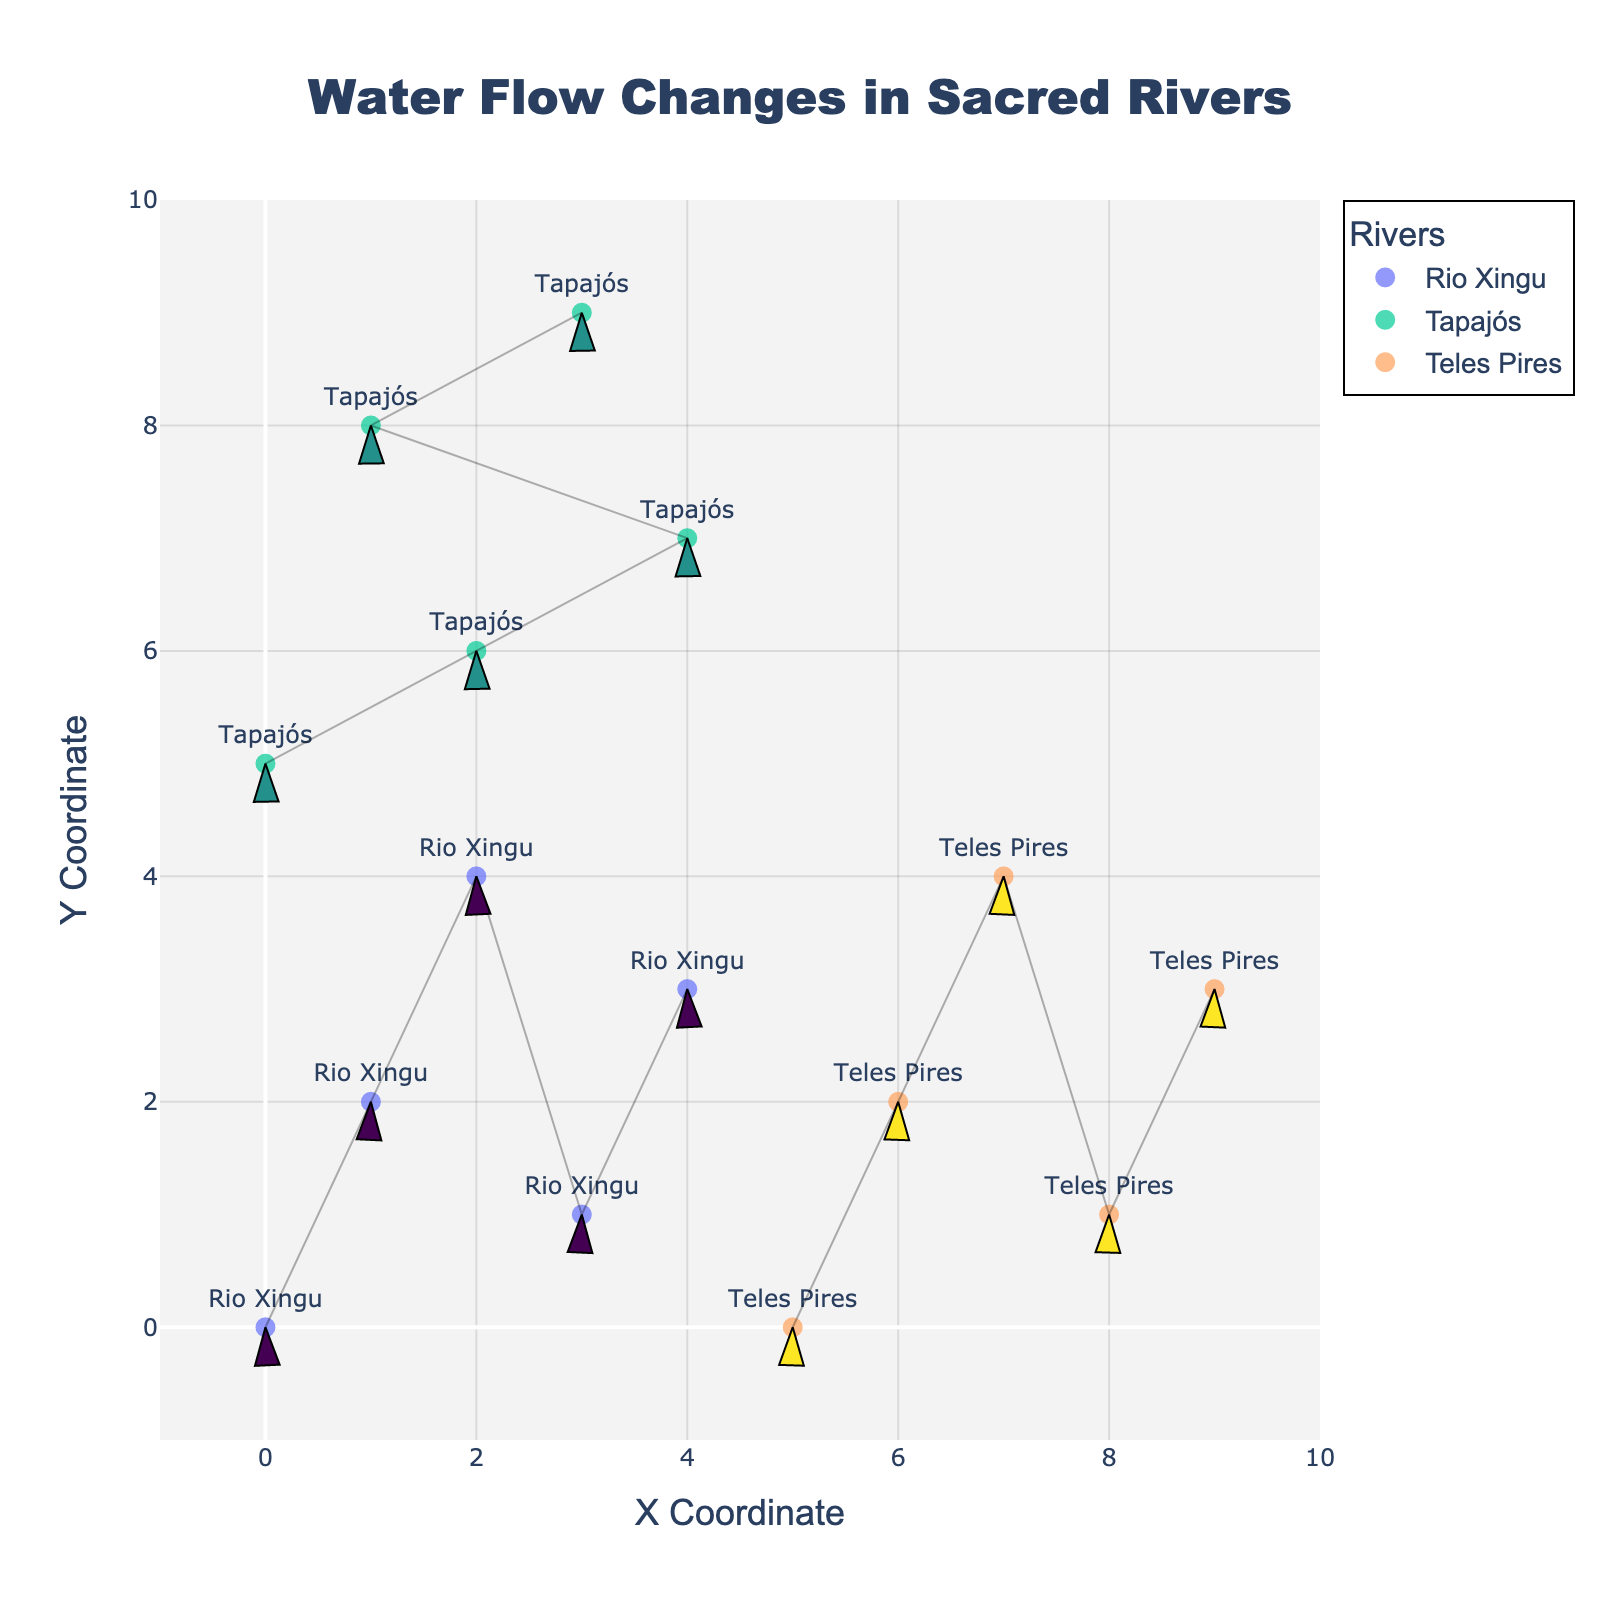What's the title of the figure? The title is typically located at the top of the figure and in larger, distinct font size.
Answer: "Water Flow Changes in Sacred Rivers" What are the names of the rivers shown in the figure? The river names are displayed next to the data points in the figure. These are markers with text labels corresponding to each river.
Answer: Rio Xingu, Tapajós, Teles Pires How many data points are there for each river? Each data point is marked and labeled with the river's name. Count these markers for each river to find the total.
Answer: Rio Xingu: 5, Tapajós: 5, Teles Pires: 5 Which river has the most negative u-component (velocity in the x direction) in its flow? Examine the labels showing the u-component values and identify the smallest (most negative) one. The arrow directions can also provide a clue.
Answer: Rio Xingu (-0.7) Between Rio Xingu and Teles Pires, which river has a higher range in the y-coordinates of its data points? Look at the vertical positions of the data points for each river, determine the maximum and minimum y-coordinates, and compare their ranges.
Answer: Tapajós (range 3) How does the direction of water flow differ between Rio Xingu and Tapajós? Examine the direction of the arrows representing flow. Rio Xingu has predominantly negative u-components (leftward) and varying v-components, while Tapajós mostly has positive u-components (rightward) and negative v-components.
Answer: Rio Xingu: leftward; Tapajós: rightward Comparing the river flow at x=4 for all rivers, which river has the smallest magnitude of velocity? Calculate the magnitude √(u^2 + v^2) of the velocity vectors at x=4 for each river and find the smallest value.
Answer: Teles Pires (√(0.3² + 0.2²) = 0.36) What's the primary flow direction of Teles Pires? Observe the direction in which most of the arrows point for Teles Pires data points, considering both u and v components.
Answer: Upward What's the average u-component for Rio Xingu? Sum up the u-components for Rio Xingu and divide by the number of data points (5). The u-components are -0.5, -0.3, -0.6, -0.4, and -0.7.
Answer: -0.5 Which river seems to have the most stable flow pattern in terms of direction? Compare the consistencies in the directions of the arrows for each river, noting which one varies the least.
Answer: Teles Pires 